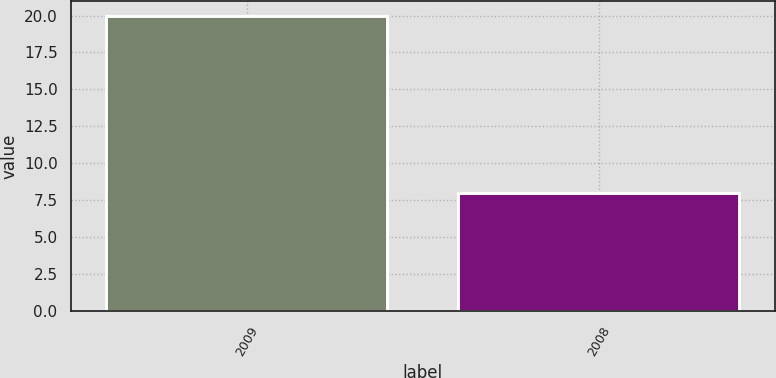Convert chart. <chart><loc_0><loc_0><loc_500><loc_500><bar_chart><fcel>2009<fcel>2008<nl><fcel>20<fcel>8<nl></chart> 